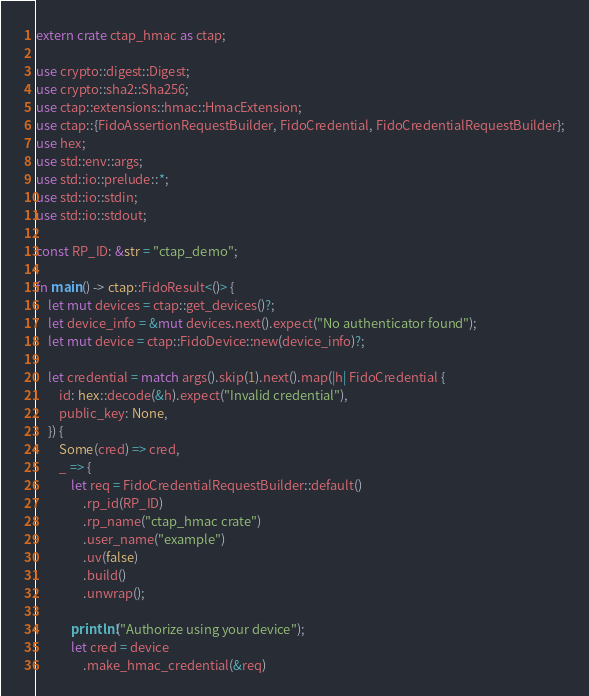<code> <loc_0><loc_0><loc_500><loc_500><_Rust_>extern crate ctap_hmac as ctap;

use crypto::digest::Digest;
use crypto::sha2::Sha256;
use ctap::extensions::hmac::HmacExtension;
use ctap::{FidoAssertionRequestBuilder, FidoCredential, FidoCredentialRequestBuilder};
use hex;
use std::env::args;
use std::io::prelude::*;
use std::io::stdin;
use std::io::stdout;

const RP_ID: &str = "ctap_demo";

fn main() -> ctap::FidoResult<()> {
    let mut devices = ctap::get_devices()?;
    let device_info = &mut devices.next().expect("No authenticator found");
    let mut device = ctap::FidoDevice::new(device_info)?;

    let credential = match args().skip(1).next().map(|h| FidoCredential {
        id: hex::decode(&h).expect("Invalid credential"),
        public_key: None,
    }) {
        Some(cred) => cred,
        _ => {
            let req = FidoCredentialRequestBuilder::default()
                .rp_id(RP_ID)
                .rp_name("ctap_hmac crate")
                .user_name("example")
                .uv(false)
                .build()
                .unwrap();

            println!("Authorize using your device");
            let cred = device
                .make_hmac_credential(&req)</code> 